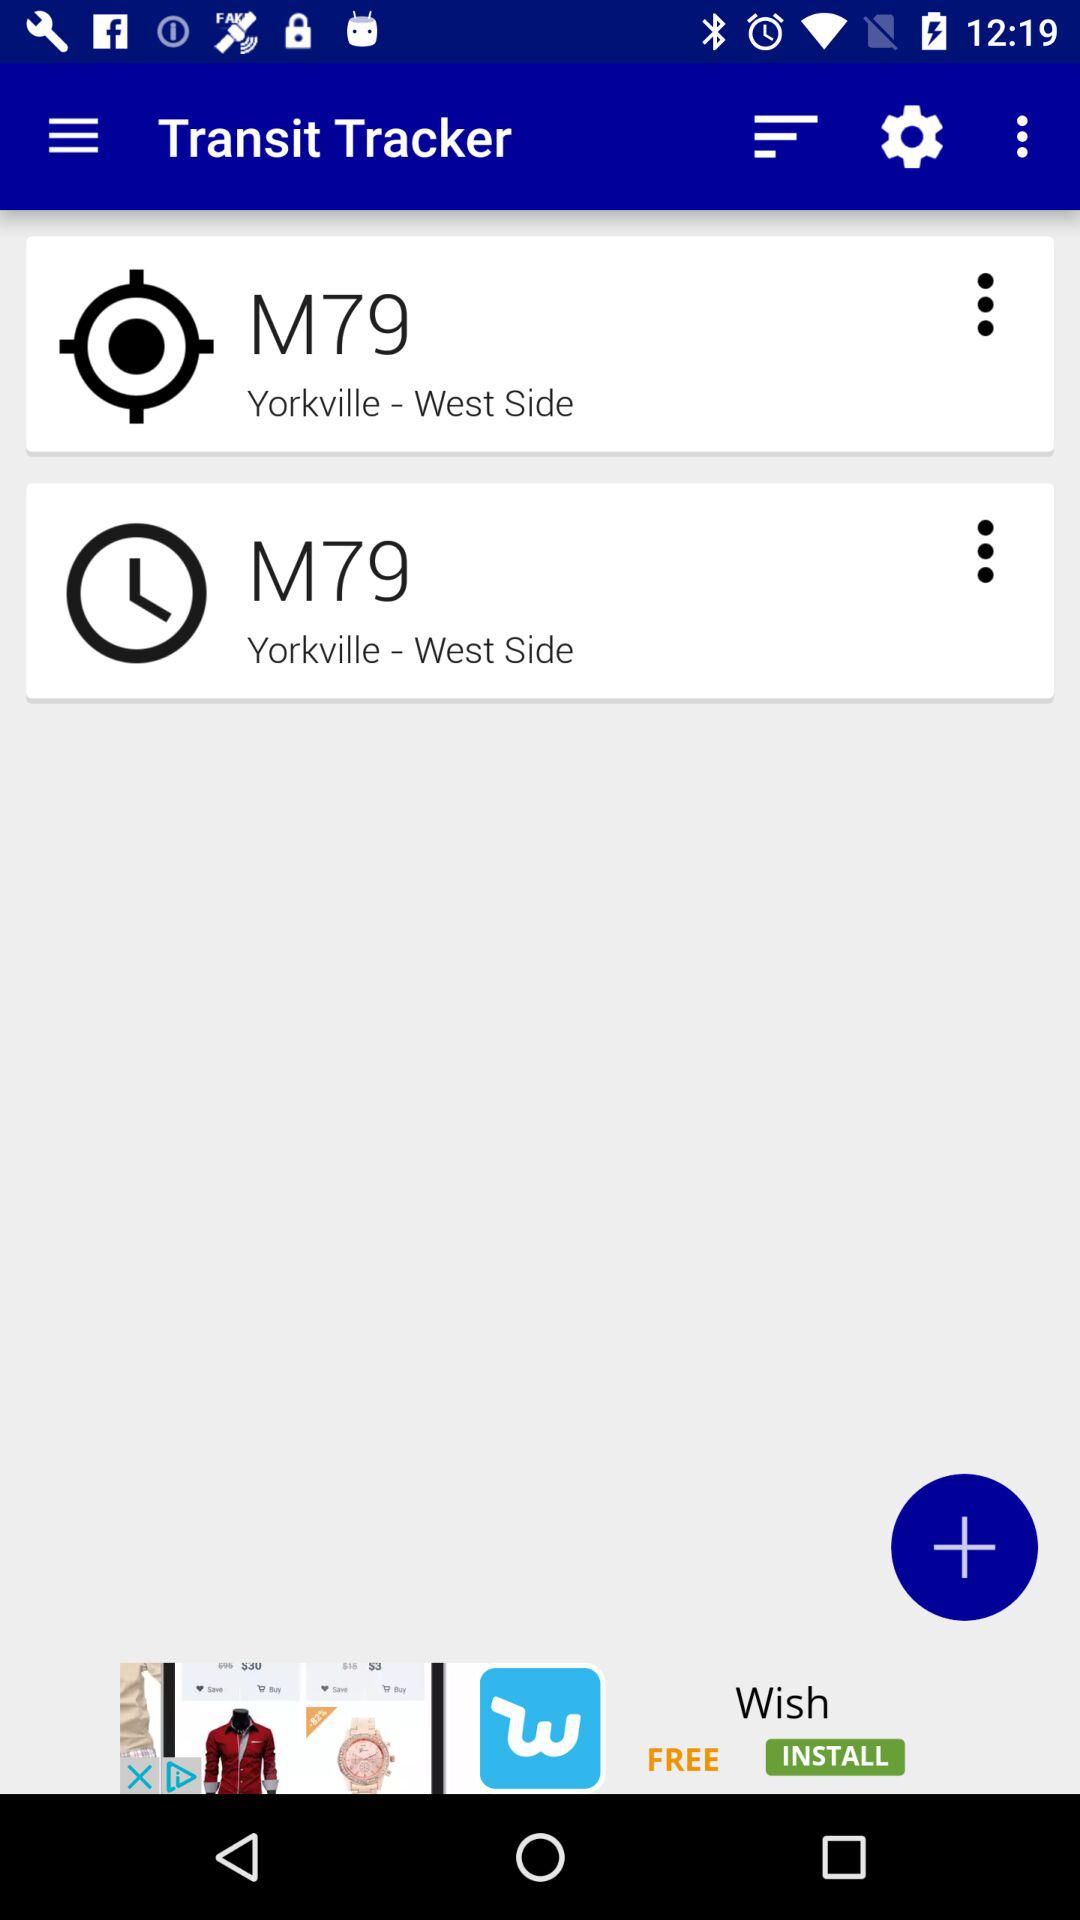What is the name of the application? The name of the application is "Transit Tracker". 